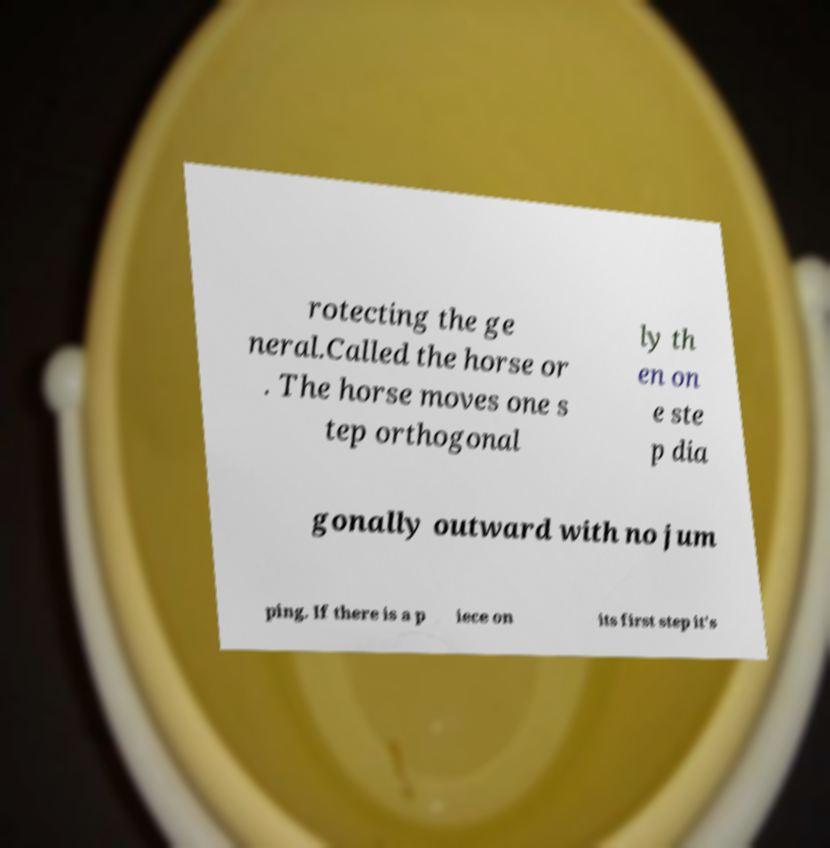Can you accurately transcribe the text from the provided image for me? rotecting the ge neral.Called the horse or . The horse moves one s tep orthogonal ly th en on e ste p dia gonally outward with no jum ping. If there is a p iece on its first step it's 